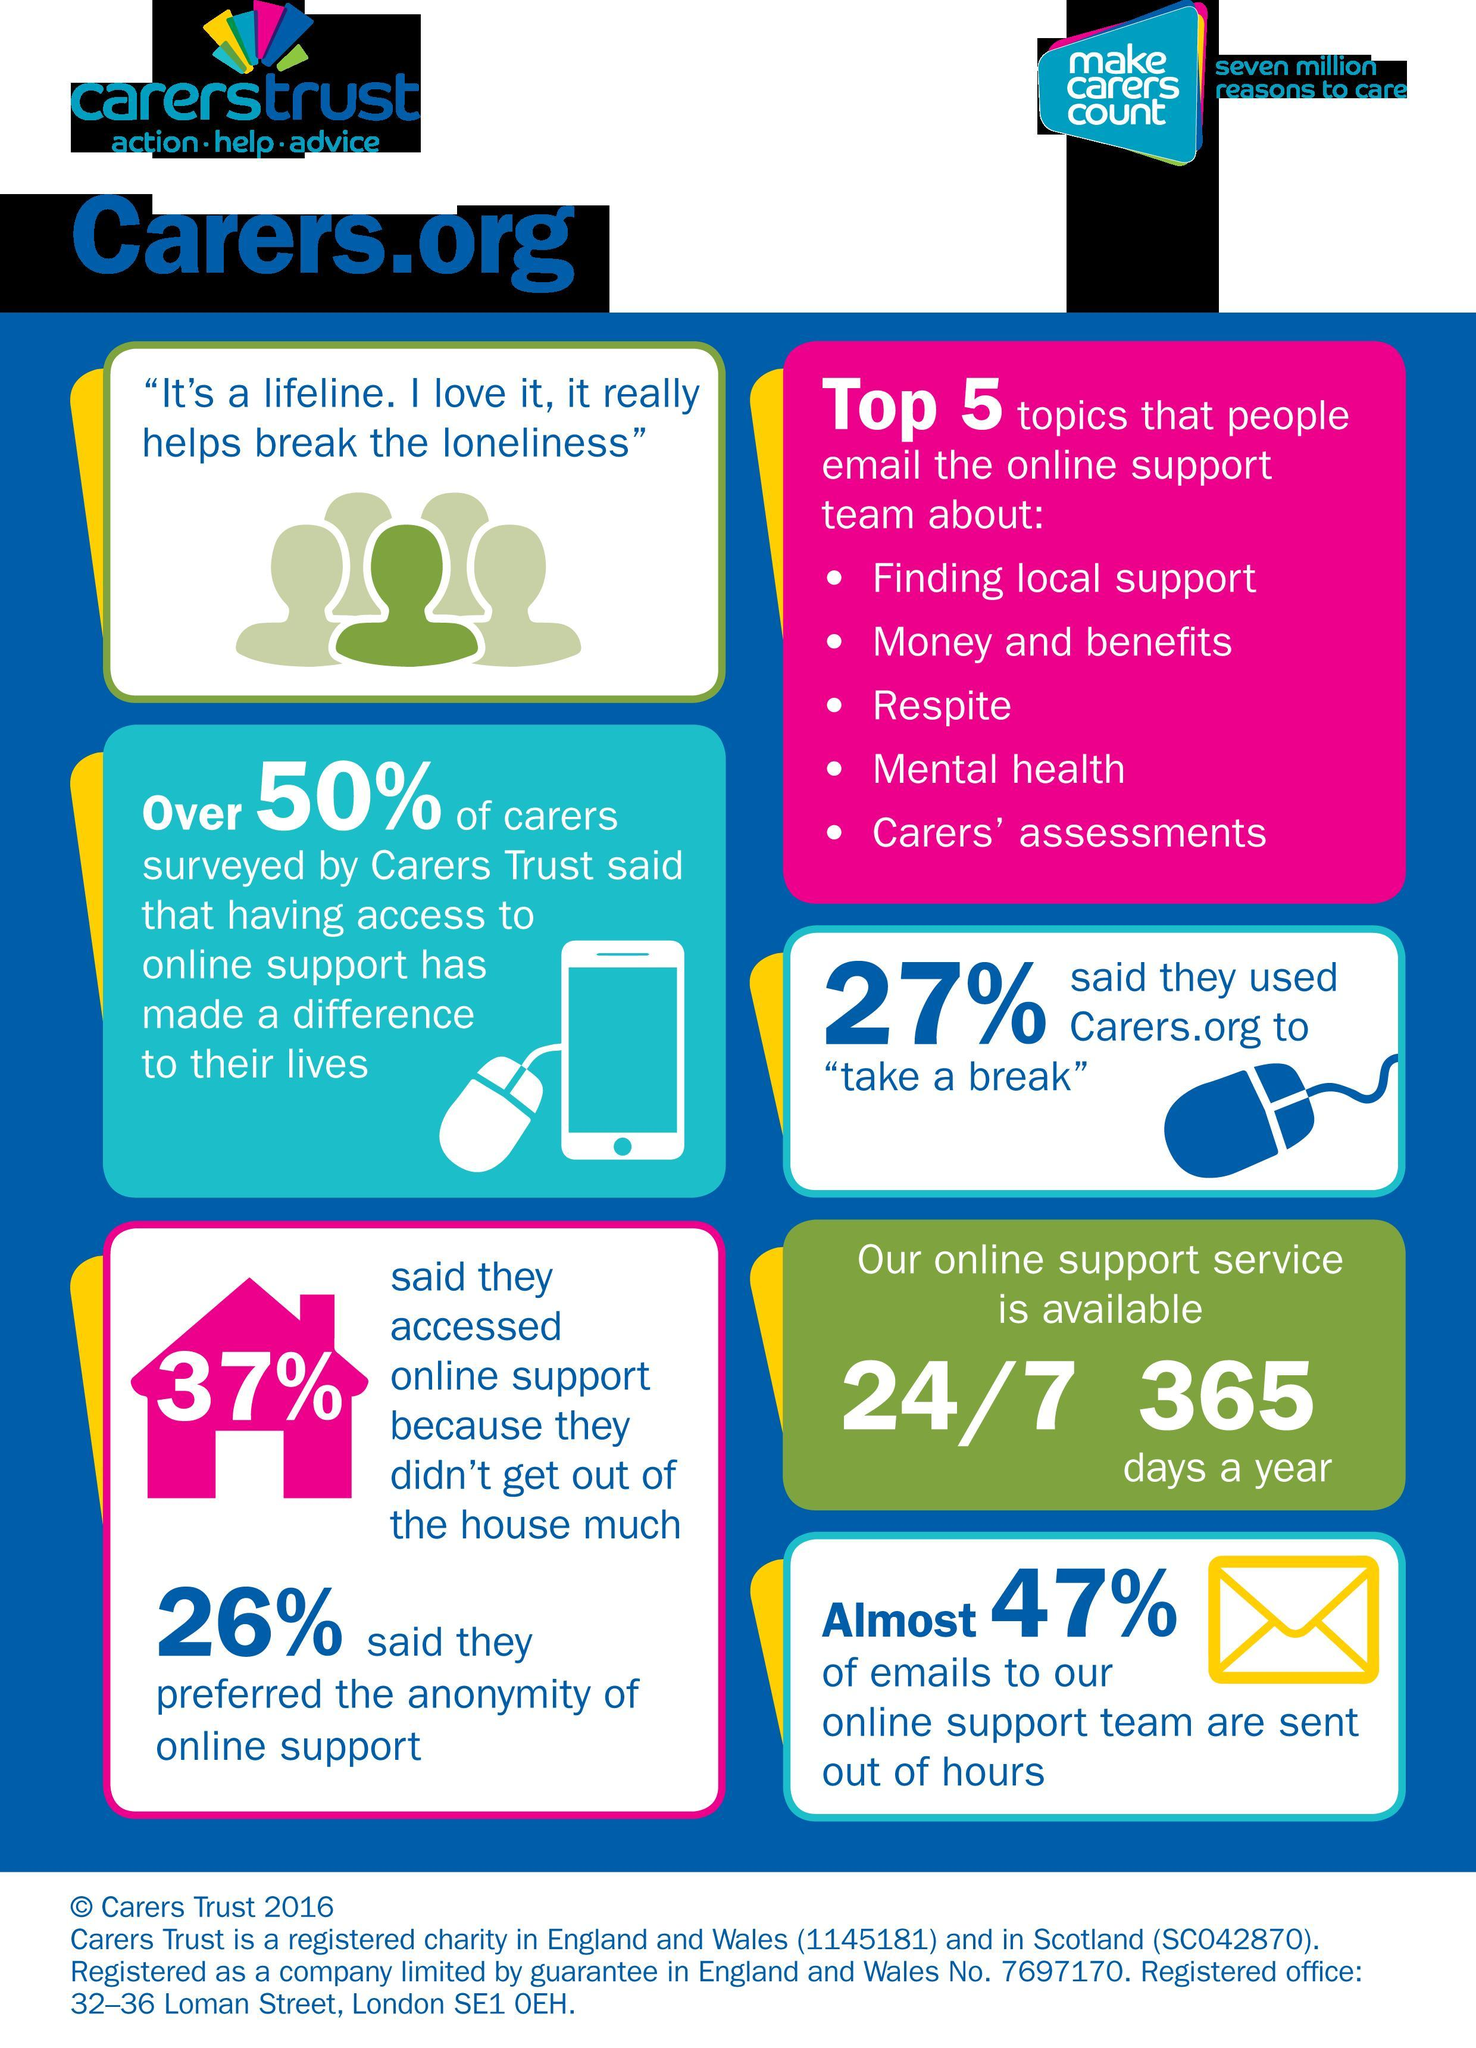What is the working time of Carers.Org?
Answer the question with a short phrase. 24/7 365 days a year What percentage of emails to Carers Online support team have been sent in the day hours? 53 What is the second topic mentioned in the email to online support team? Money and benefits What is the fourth topic mentioned in the email to online support team? Mental Health What percentage of people have not contacted carers.org to take a break? 73 